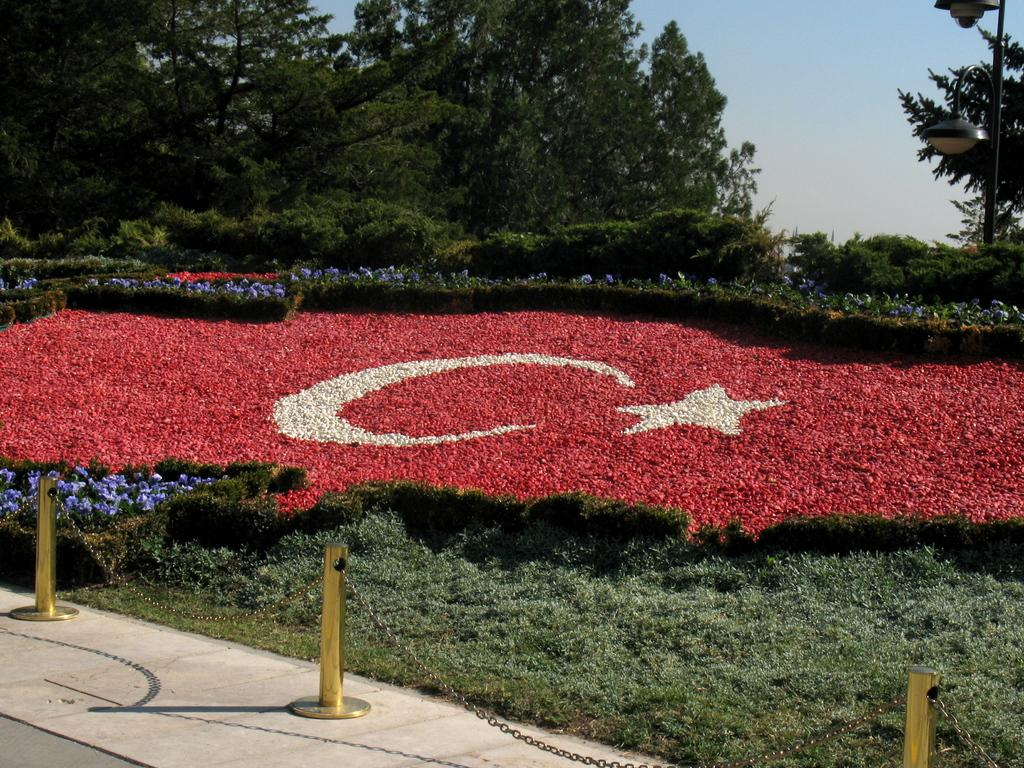What type of barrier can be seen on the platform in the image? There are poles and chains forming a barrier on a platform in the image. What kind of vegetation is present in the image? There are plants with flowers and grass in the image. Can you describe the lighting in the image? There are lights on a pole on the right side of the image. What other natural elements can be seen in the image? Trees are visible in the image. What is visible in the sky in the image? Clouds are present in the sky. Where is the harbor located in the image? There is no harbor present in the image. What type of drug is being used by the person in the image? There is no person or drug present in the image. Can you describe the relationship between the two brothers in the image? There are no people, let alone brothers, present in the image. 